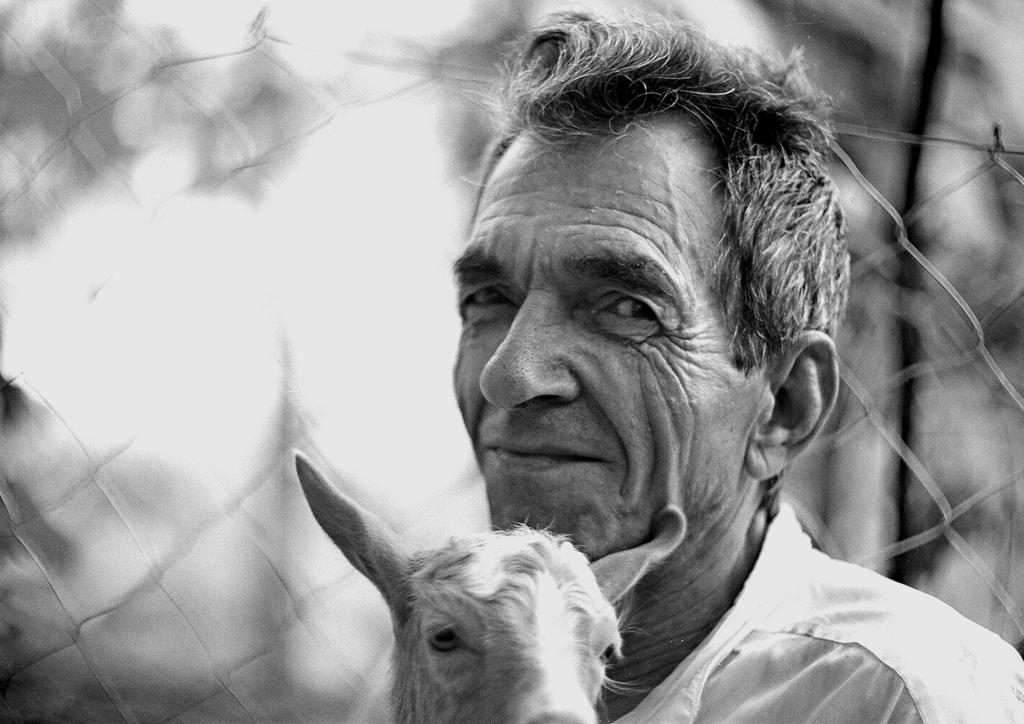Who is present in the image? There is a man in the image. What other living creature is present in the image? There is an animal in the image. Can you describe the background of the image? The background of the image is blurry. What type of material can be seen in the background? Mesh is visible in the background of the image. What type of prison is depicted in the image? There is no prison present in the image; it features a man and an animal with a blurry, mesh-filled background. Can you point out the map in the image? There is no map present in the image. 